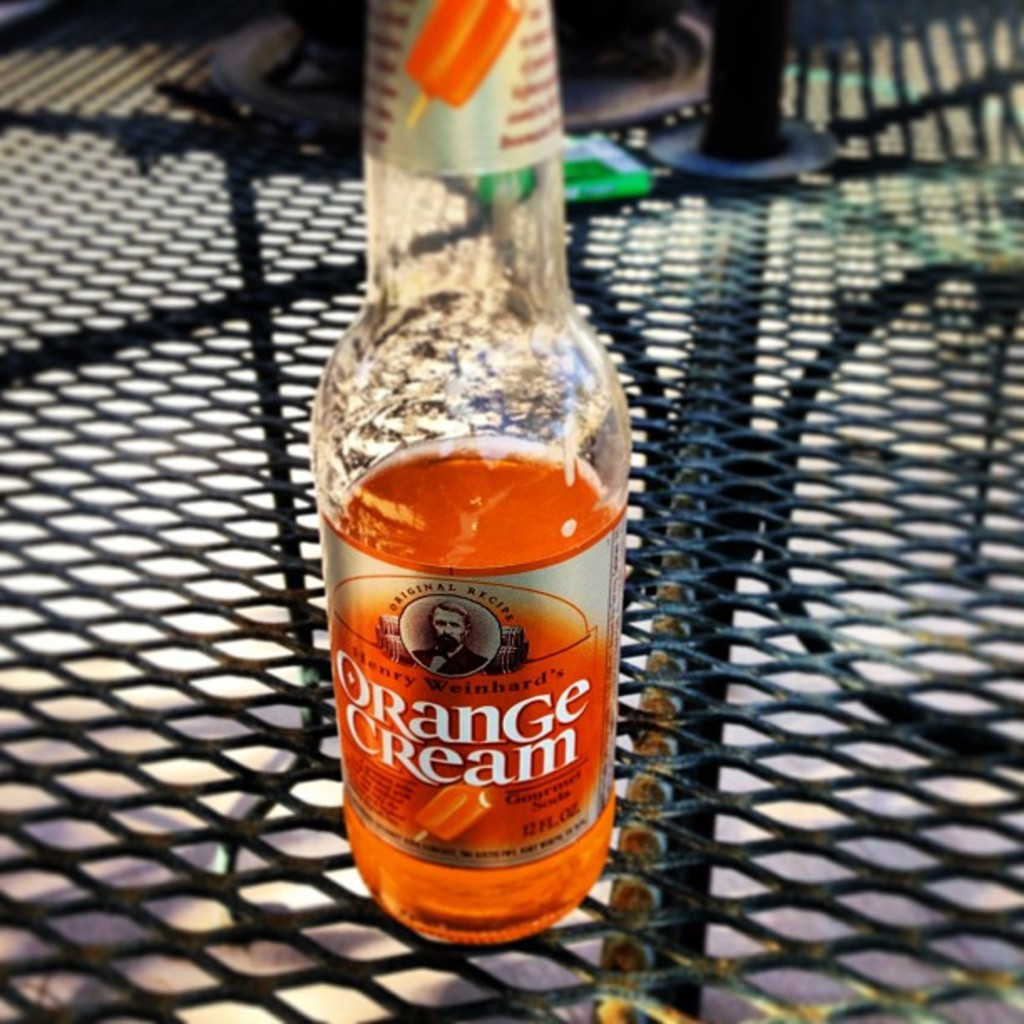Can you imagine a scenario in which this soda is being enjoyed? Certainly! Picture a laid-back family barbecue on a sunny weekend, laughter fills the air as this nostalgic Orange Cream soda is sipped from chilled glasses, complementing the smoky flavors from the grill. 